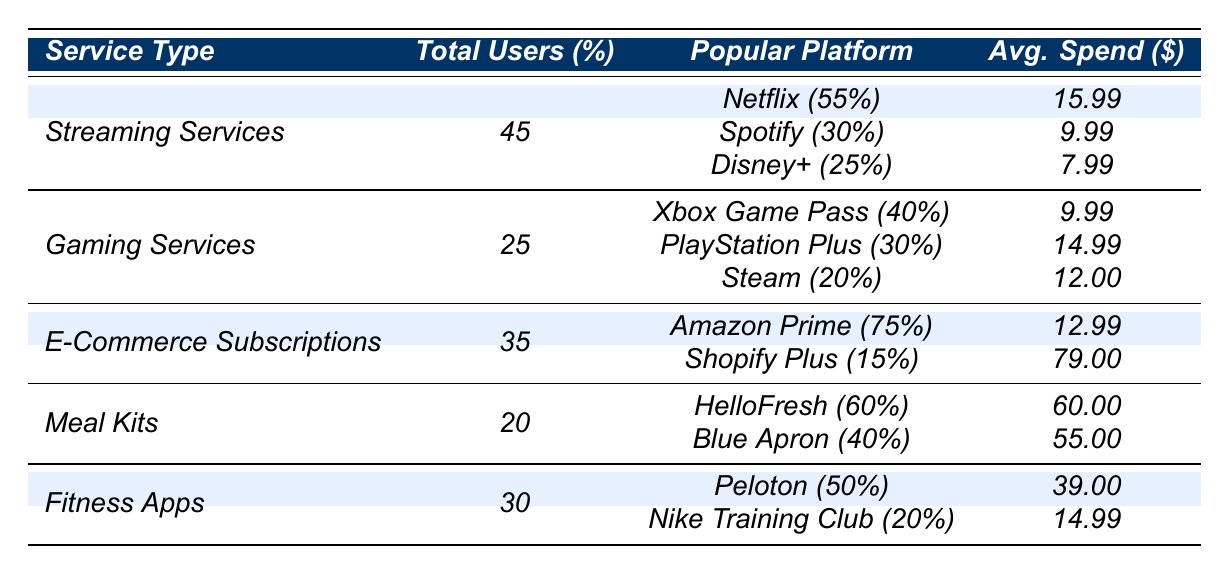What percentage of Millennials use Netflix? The table shows that Netflix has a percentage of 55% among streaming services used by Millennials.
Answer: 55% What is the average spend for a Spotify user? According to the table, the average spend for Spotify users is $9.99.
Answer: $9.99 How many total users are engaged with Gaming Services? The table indicates that 25 Millennials are engaged with Gaming Services.
Answer: 25 What is the ratio of Amazon Prime users to total e-commerce subscription users? Amazon Prime users make up 75% of the total 35 e-commerce subscription users, so the ratio is 75/35 or approximately 2.14.
Answer: 2.14 Which meal kit service has a higher average spend: HelloFresh or Blue Apron? The table indicates that HelloFresh has an average spend of $60.00, while Blue Apron's average spend is $55.00. Therefore, HelloFresh has the higher average spend.
Answer: HelloFresh Is the percentage of users for PlayStation Plus greater than that for Steam? The table shows that PlayStation Plus has 30% and Steam has 20%, thus PlayStation Plus is greater.
Answer: Yes What is the total average spend for all fitness app users combined? Peloton users spend $39.00 and Nike Training Club users spend $14.99. The total average spend is $39.00 + $14.99 = $53.99.
Answer: $53.99 Which service type has the highest average spend per user among the listed categories? Comparing the averages across all categories, the highest average spend is for Shopify Plus at $79.00.
Answer: Shopify Plus How many more users are there in Streaming Services than in Meal Kits? Streaming Services have 45 users and Meal Kits have 20 users. The difference is 45 - 20 = 25.
Answer: 25 What is the combined percentage of users for Xbox Game Pass and PlayStation Plus? Xbox Game Pass has 40% and PlayStation Plus has 30%, combining yields 40% + 30% = 70%.
Answer: 70% 